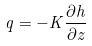<formula> <loc_0><loc_0><loc_500><loc_500>q = - K \frac { \partial h } { \partial z }</formula> 